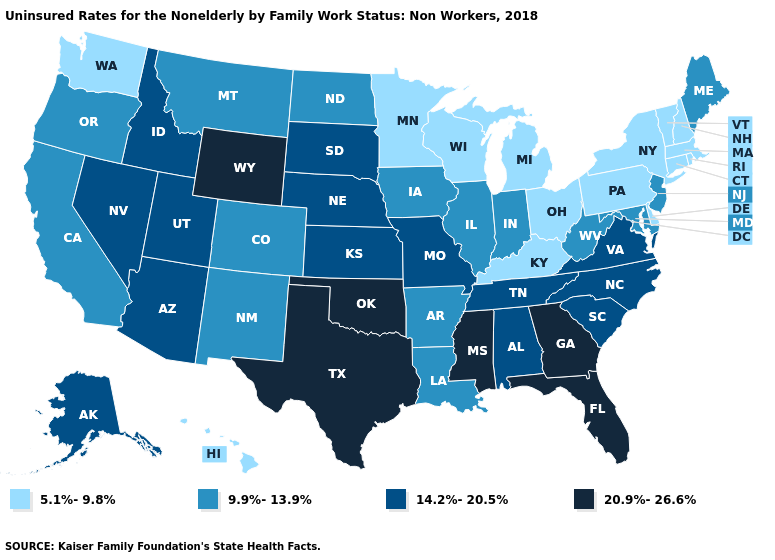What is the lowest value in the USA?
Short answer required. 5.1%-9.8%. Which states hav the highest value in the South?
Answer briefly. Florida, Georgia, Mississippi, Oklahoma, Texas. Which states have the lowest value in the Northeast?
Give a very brief answer. Connecticut, Massachusetts, New Hampshire, New York, Pennsylvania, Rhode Island, Vermont. How many symbols are there in the legend?
Answer briefly. 4. What is the value of Pennsylvania?
Write a very short answer. 5.1%-9.8%. Does Colorado have the lowest value in the USA?
Keep it brief. No. Name the states that have a value in the range 20.9%-26.6%?
Quick response, please. Florida, Georgia, Mississippi, Oklahoma, Texas, Wyoming. What is the value of Louisiana?
Short answer required. 9.9%-13.9%. Name the states that have a value in the range 20.9%-26.6%?
Quick response, please. Florida, Georgia, Mississippi, Oklahoma, Texas, Wyoming. Among the states that border Vermont , which have the lowest value?
Write a very short answer. Massachusetts, New Hampshire, New York. Name the states that have a value in the range 5.1%-9.8%?
Give a very brief answer. Connecticut, Delaware, Hawaii, Kentucky, Massachusetts, Michigan, Minnesota, New Hampshire, New York, Ohio, Pennsylvania, Rhode Island, Vermont, Washington, Wisconsin. Does California have the lowest value in the West?
Write a very short answer. No. What is the value of Utah?
Short answer required. 14.2%-20.5%. What is the value of Idaho?
Give a very brief answer. 14.2%-20.5%. Does Ohio have a lower value than Massachusetts?
Short answer required. No. 